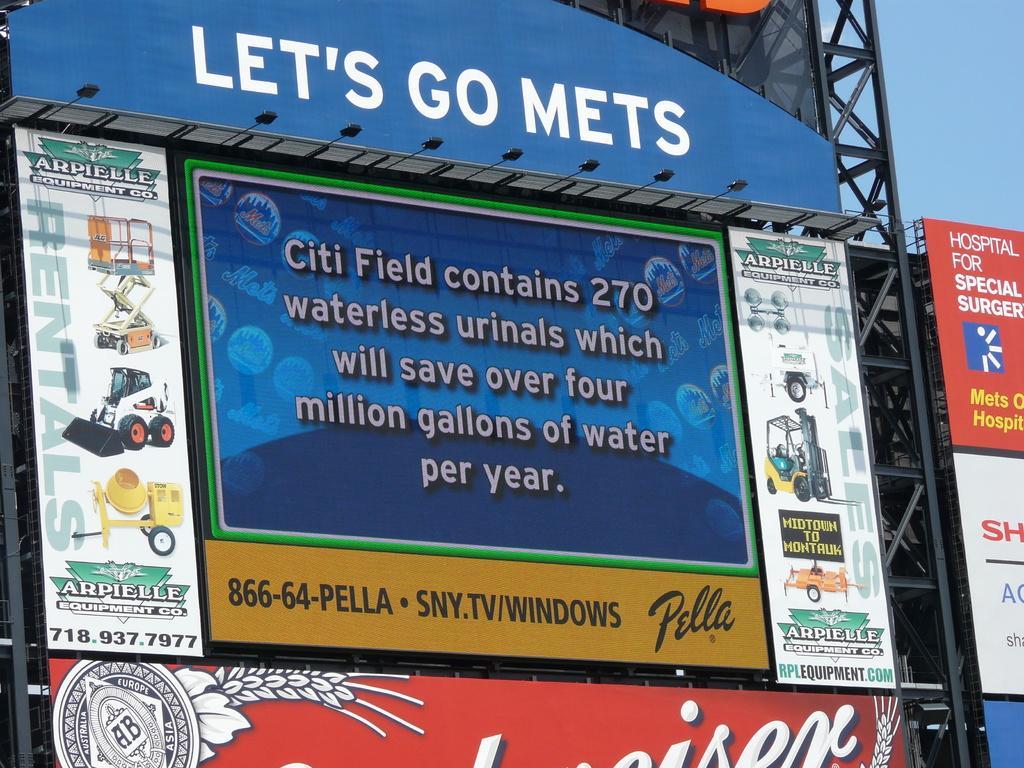How would you summarize this image in a sentence or two? In this image, we can see some boards with text and images. We can also see some metal towers and a few black colored objects. We can also see the sky. 